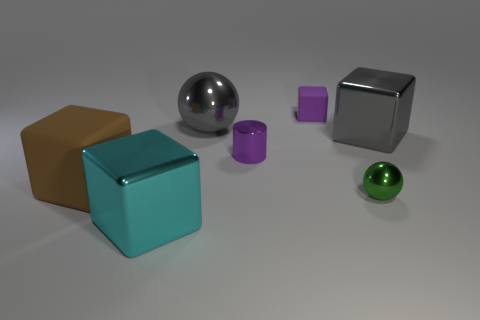What number of other objects are the same size as the purple cylinder?
Ensure brevity in your answer.  2. Are there more purple things that are in front of the purple rubber object than tiny red blocks?
Your answer should be very brief. Yes. The shiny thing that is the same color as the tiny rubber object is what shape?
Provide a succinct answer. Cylinder. How many blocks are either green things or cyan metallic things?
Your answer should be very brief. 1. There is a metallic sphere to the left of the matte cube that is behind the big brown rubber cube; what color is it?
Ensure brevity in your answer.  Gray. There is a cylinder; is it the same color as the matte object right of the big cyan object?
Offer a terse response. Yes. There is a cylinder that is made of the same material as the large ball; what is its size?
Keep it short and to the point. Small. What is the size of the metal cylinder that is the same color as the tiny rubber thing?
Keep it short and to the point. Small. Is the small cube the same color as the small metallic cylinder?
Provide a short and direct response. Yes. Are there any small green things behind the shiny block in front of the big object on the left side of the large cyan block?
Ensure brevity in your answer.  Yes. 